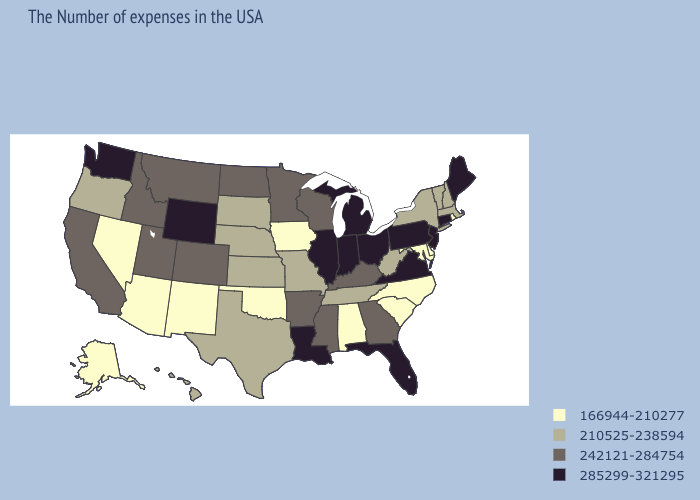Name the states that have a value in the range 242121-284754?
Keep it brief. Georgia, Kentucky, Wisconsin, Mississippi, Arkansas, Minnesota, North Dakota, Colorado, Utah, Montana, Idaho, California. Name the states that have a value in the range 166944-210277?
Quick response, please. Rhode Island, Delaware, Maryland, North Carolina, South Carolina, Alabama, Iowa, Oklahoma, New Mexico, Arizona, Nevada, Alaska. Name the states that have a value in the range 242121-284754?
Be succinct. Georgia, Kentucky, Wisconsin, Mississippi, Arkansas, Minnesota, North Dakota, Colorado, Utah, Montana, Idaho, California. What is the value of Texas?
Be succinct. 210525-238594. What is the highest value in the USA?
Short answer required. 285299-321295. Does the map have missing data?
Answer briefly. No. Among the states that border South Dakota , does Iowa have the highest value?
Concise answer only. No. Does the map have missing data?
Answer briefly. No. Name the states that have a value in the range 166944-210277?
Answer briefly. Rhode Island, Delaware, Maryland, North Carolina, South Carolina, Alabama, Iowa, Oklahoma, New Mexico, Arizona, Nevada, Alaska. Name the states that have a value in the range 166944-210277?
Answer briefly. Rhode Island, Delaware, Maryland, North Carolina, South Carolina, Alabama, Iowa, Oklahoma, New Mexico, Arizona, Nevada, Alaska. Name the states that have a value in the range 285299-321295?
Concise answer only. Maine, Connecticut, New Jersey, Pennsylvania, Virginia, Ohio, Florida, Michigan, Indiana, Illinois, Louisiana, Wyoming, Washington. Which states have the highest value in the USA?
Answer briefly. Maine, Connecticut, New Jersey, Pennsylvania, Virginia, Ohio, Florida, Michigan, Indiana, Illinois, Louisiana, Wyoming, Washington. Which states have the highest value in the USA?
Quick response, please. Maine, Connecticut, New Jersey, Pennsylvania, Virginia, Ohio, Florida, Michigan, Indiana, Illinois, Louisiana, Wyoming, Washington. Which states hav the highest value in the South?
Concise answer only. Virginia, Florida, Louisiana. 